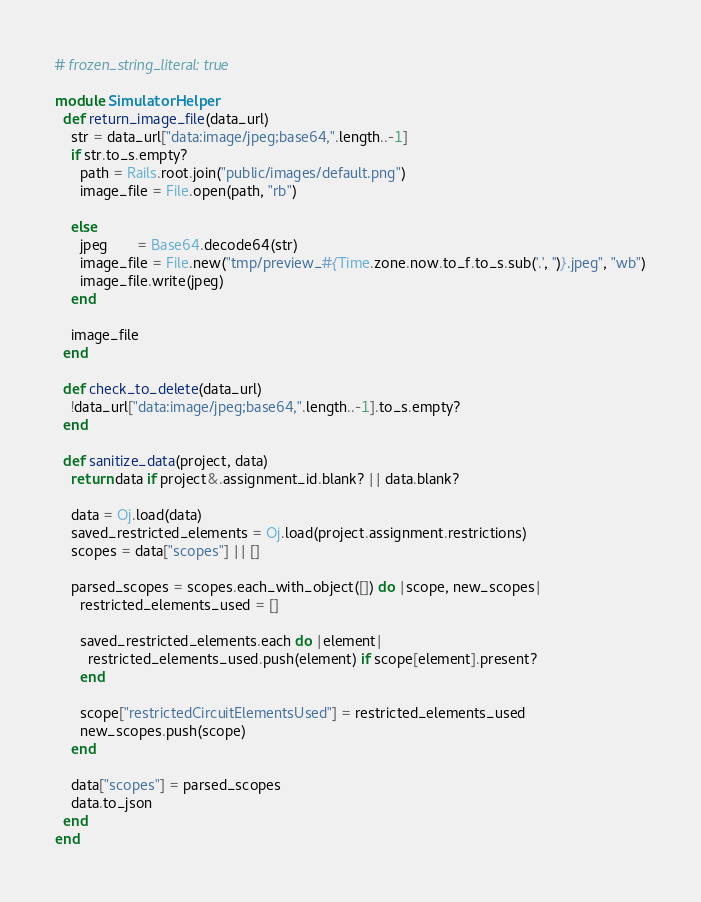Convert code to text. <code><loc_0><loc_0><loc_500><loc_500><_Ruby_># frozen_string_literal: true

module SimulatorHelper
  def return_image_file(data_url)
    str = data_url["data:image/jpeg;base64,".length..-1]
    if str.to_s.empty?
      path = Rails.root.join("public/images/default.png")
      image_file = File.open(path, "rb")

    else
      jpeg       = Base64.decode64(str)
      image_file = File.new("tmp/preview_#{Time.zone.now.to_f.to_s.sub('.', '')}.jpeg", "wb")
      image_file.write(jpeg)
    end

    image_file
  end

  def check_to_delete(data_url)
    !data_url["data:image/jpeg;base64,".length..-1].to_s.empty?
  end

  def sanitize_data(project, data)
    return data if project&.assignment_id.blank? || data.blank?

    data = Oj.load(data)
    saved_restricted_elements = Oj.load(project.assignment.restrictions)
    scopes = data["scopes"] || []

    parsed_scopes = scopes.each_with_object([]) do |scope, new_scopes|
      restricted_elements_used = []

      saved_restricted_elements.each do |element|
        restricted_elements_used.push(element) if scope[element].present?
      end

      scope["restrictedCircuitElementsUsed"] = restricted_elements_used
      new_scopes.push(scope)
    end

    data["scopes"] = parsed_scopes
    data.to_json
  end
end
</code> 